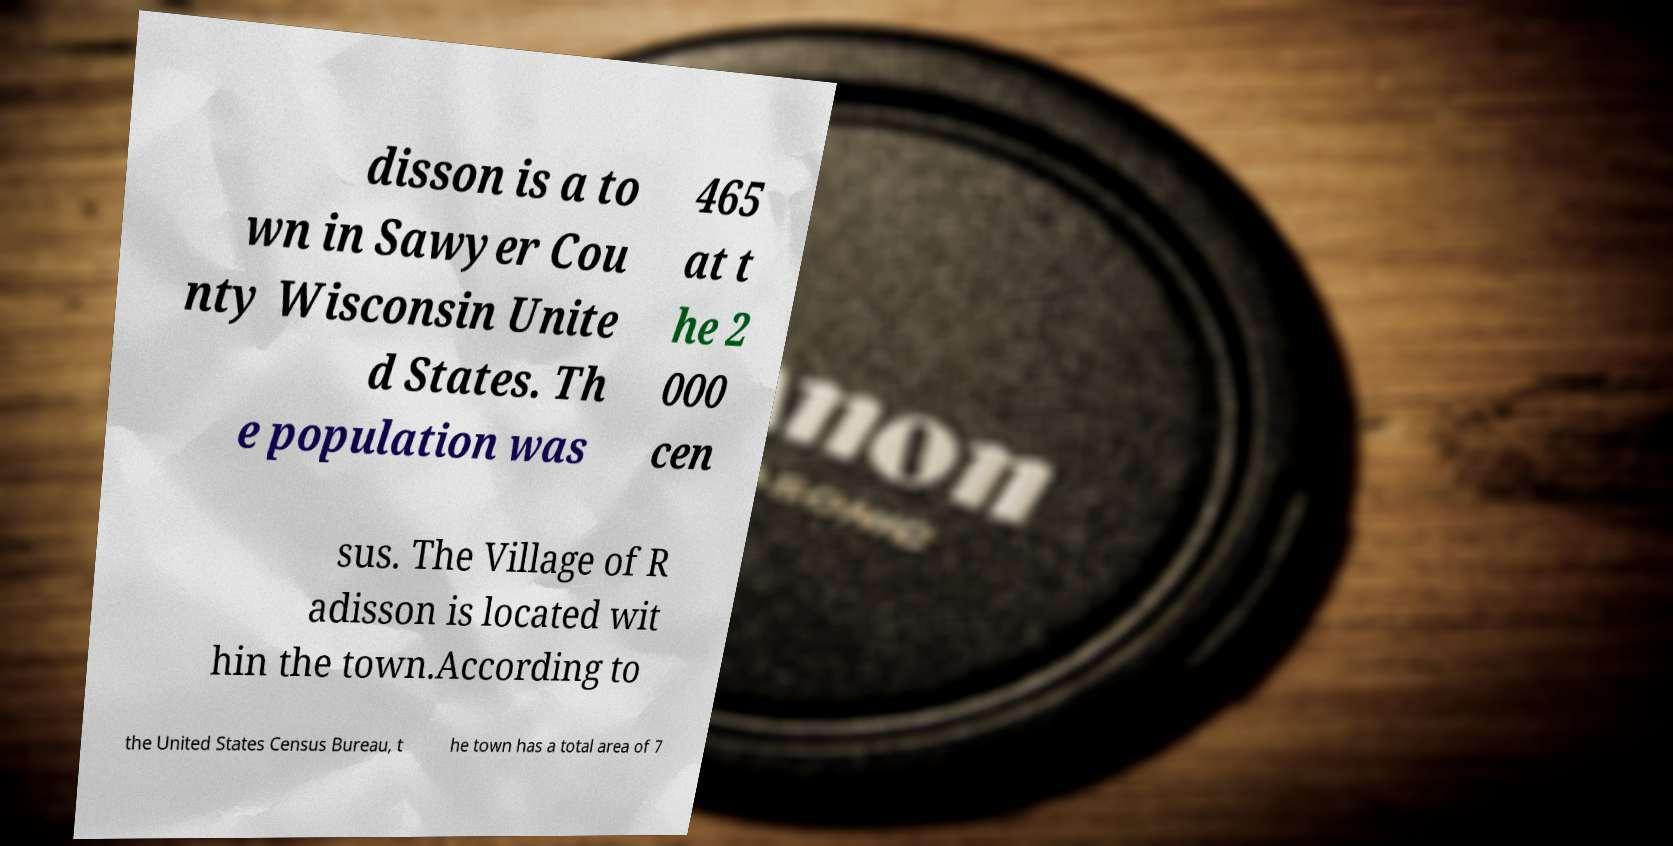Could you assist in decoding the text presented in this image and type it out clearly? disson is a to wn in Sawyer Cou nty Wisconsin Unite d States. Th e population was 465 at t he 2 000 cen sus. The Village of R adisson is located wit hin the town.According to the United States Census Bureau, t he town has a total area of 7 